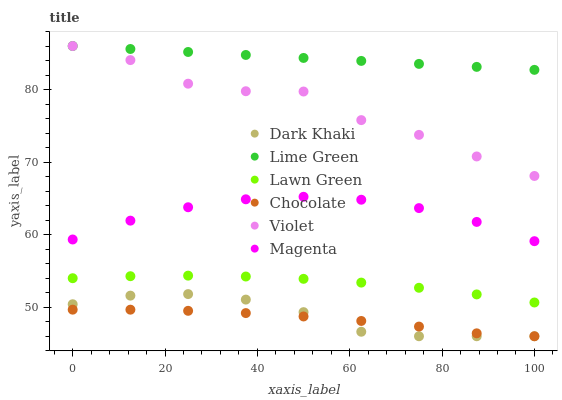Does Chocolate have the minimum area under the curve?
Answer yes or no. Yes. Does Lime Green have the maximum area under the curve?
Answer yes or no. Yes. Does Dark Khaki have the minimum area under the curve?
Answer yes or no. No. Does Dark Khaki have the maximum area under the curve?
Answer yes or no. No. Is Lime Green the smoothest?
Answer yes or no. Yes. Is Violet the roughest?
Answer yes or no. Yes. Is Chocolate the smoothest?
Answer yes or no. No. Is Chocolate the roughest?
Answer yes or no. No. Does Chocolate have the lowest value?
Answer yes or no. Yes. Does Violet have the lowest value?
Answer yes or no. No. Does Lime Green have the highest value?
Answer yes or no. Yes. Does Dark Khaki have the highest value?
Answer yes or no. No. Is Chocolate less than Lime Green?
Answer yes or no. Yes. Is Lime Green greater than Chocolate?
Answer yes or no. Yes. Does Violet intersect Lime Green?
Answer yes or no. Yes. Is Violet less than Lime Green?
Answer yes or no. No. Is Violet greater than Lime Green?
Answer yes or no. No. Does Chocolate intersect Lime Green?
Answer yes or no. No. 